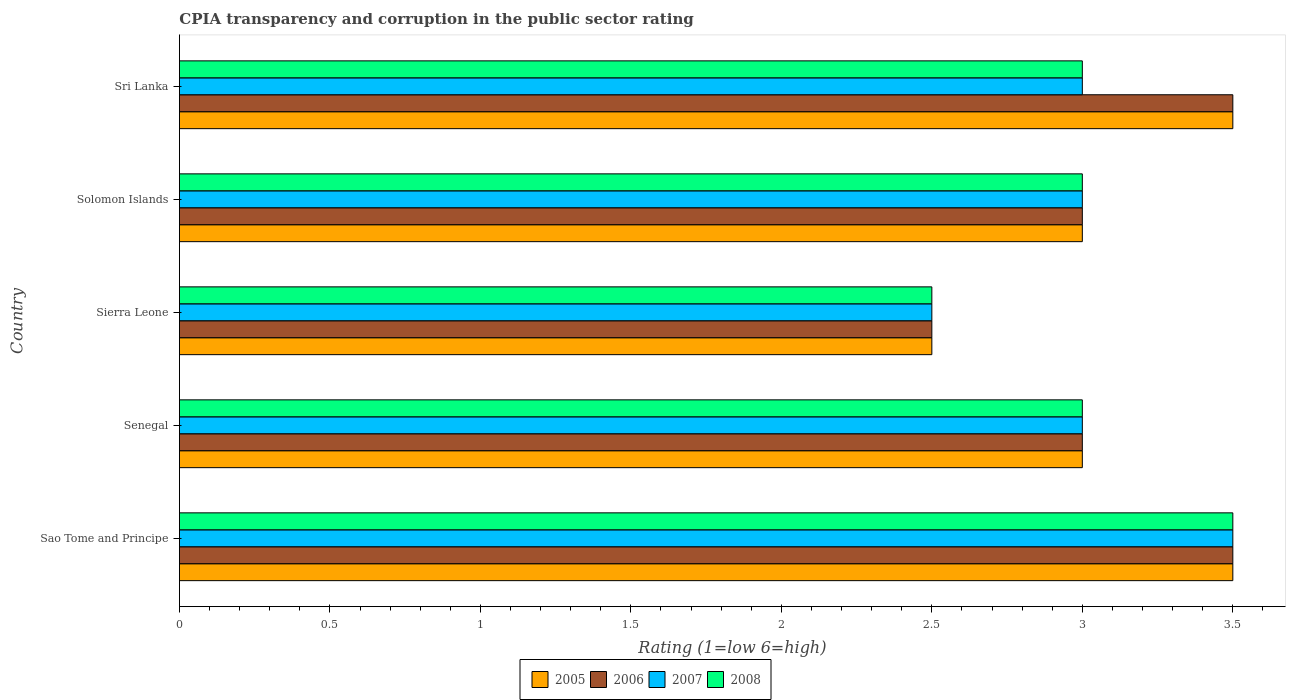How many different coloured bars are there?
Provide a succinct answer. 4. Are the number of bars per tick equal to the number of legend labels?
Offer a terse response. Yes. How many bars are there on the 1st tick from the bottom?
Your answer should be very brief. 4. What is the label of the 2nd group of bars from the top?
Your response must be concise. Solomon Islands. In how many cases, is the number of bars for a given country not equal to the number of legend labels?
Offer a very short reply. 0. Across all countries, what is the minimum CPIA rating in 2006?
Make the answer very short. 2.5. In which country was the CPIA rating in 2008 maximum?
Provide a succinct answer. Sao Tome and Principe. In which country was the CPIA rating in 2005 minimum?
Offer a very short reply. Sierra Leone. What is the total CPIA rating in 2008 in the graph?
Your answer should be very brief. 15. In how many countries, is the CPIA rating in 2007 greater than 1.3 ?
Ensure brevity in your answer.  5. What is the ratio of the CPIA rating in 2005 in Senegal to that in Sri Lanka?
Ensure brevity in your answer.  0.86. Is the CPIA rating in 2006 in Sierra Leone less than that in Solomon Islands?
Your response must be concise. Yes. In how many countries, is the CPIA rating in 2007 greater than the average CPIA rating in 2007 taken over all countries?
Offer a terse response. 1. Is it the case that in every country, the sum of the CPIA rating in 2006 and CPIA rating in 2008 is greater than the sum of CPIA rating in 2007 and CPIA rating in 2005?
Keep it short and to the point. No. Is it the case that in every country, the sum of the CPIA rating in 2006 and CPIA rating in 2008 is greater than the CPIA rating in 2005?
Make the answer very short. Yes. Are all the bars in the graph horizontal?
Provide a succinct answer. Yes. What is the difference between two consecutive major ticks on the X-axis?
Provide a succinct answer. 0.5. How are the legend labels stacked?
Offer a terse response. Horizontal. What is the title of the graph?
Offer a terse response. CPIA transparency and corruption in the public sector rating. Does "2012" appear as one of the legend labels in the graph?
Give a very brief answer. No. What is the label or title of the X-axis?
Make the answer very short. Rating (1=low 6=high). What is the label or title of the Y-axis?
Make the answer very short. Country. What is the Rating (1=low 6=high) in 2005 in Sao Tome and Principe?
Your answer should be compact. 3.5. What is the Rating (1=low 6=high) in 2008 in Sao Tome and Principe?
Provide a short and direct response. 3.5. What is the Rating (1=low 6=high) in 2006 in Senegal?
Offer a very short reply. 3. What is the Rating (1=low 6=high) of 2007 in Senegal?
Give a very brief answer. 3. What is the Rating (1=low 6=high) in 2008 in Senegal?
Ensure brevity in your answer.  3. What is the Rating (1=low 6=high) of 2007 in Sierra Leone?
Keep it short and to the point. 2.5. What is the Rating (1=low 6=high) in 2005 in Solomon Islands?
Provide a short and direct response. 3. What is the Rating (1=low 6=high) of 2007 in Solomon Islands?
Provide a succinct answer. 3. What is the Rating (1=low 6=high) in 2005 in Sri Lanka?
Ensure brevity in your answer.  3.5. What is the Rating (1=low 6=high) in 2006 in Sri Lanka?
Give a very brief answer. 3.5. What is the Rating (1=low 6=high) in 2008 in Sri Lanka?
Give a very brief answer. 3. Across all countries, what is the maximum Rating (1=low 6=high) in 2006?
Ensure brevity in your answer.  3.5. Across all countries, what is the minimum Rating (1=low 6=high) in 2006?
Make the answer very short. 2.5. Across all countries, what is the minimum Rating (1=low 6=high) in 2008?
Your answer should be very brief. 2.5. What is the total Rating (1=low 6=high) of 2005 in the graph?
Your answer should be compact. 15.5. What is the total Rating (1=low 6=high) in 2007 in the graph?
Make the answer very short. 15. What is the difference between the Rating (1=low 6=high) of 2006 in Sao Tome and Principe and that in Senegal?
Offer a terse response. 0.5. What is the difference between the Rating (1=low 6=high) in 2007 in Sao Tome and Principe and that in Senegal?
Your answer should be compact. 0.5. What is the difference between the Rating (1=low 6=high) in 2008 in Sao Tome and Principe and that in Senegal?
Make the answer very short. 0.5. What is the difference between the Rating (1=low 6=high) of 2005 in Sao Tome and Principe and that in Solomon Islands?
Your answer should be very brief. 0.5. What is the difference between the Rating (1=low 6=high) of 2007 in Sao Tome and Principe and that in Solomon Islands?
Your answer should be very brief. 0.5. What is the difference between the Rating (1=low 6=high) in 2008 in Sao Tome and Principe and that in Solomon Islands?
Offer a terse response. 0.5. What is the difference between the Rating (1=low 6=high) in 2007 in Sao Tome and Principe and that in Sri Lanka?
Your response must be concise. 0.5. What is the difference between the Rating (1=low 6=high) of 2008 in Sao Tome and Principe and that in Sri Lanka?
Ensure brevity in your answer.  0.5. What is the difference between the Rating (1=low 6=high) of 2007 in Senegal and that in Sierra Leone?
Ensure brevity in your answer.  0.5. What is the difference between the Rating (1=low 6=high) in 2007 in Senegal and that in Solomon Islands?
Keep it short and to the point. 0. What is the difference between the Rating (1=low 6=high) in 2006 in Senegal and that in Sri Lanka?
Provide a short and direct response. -0.5. What is the difference between the Rating (1=low 6=high) in 2008 in Senegal and that in Sri Lanka?
Provide a succinct answer. 0. What is the difference between the Rating (1=low 6=high) in 2005 in Sierra Leone and that in Sri Lanka?
Offer a very short reply. -1. What is the difference between the Rating (1=low 6=high) of 2007 in Sierra Leone and that in Sri Lanka?
Provide a short and direct response. -0.5. What is the difference between the Rating (1=low 6=high) of 2007 in Solomon Islands and that in Sri Lanka?
Ensure brevity in your answer.  0. What is the difference between the Rating (1=low 6=high) in 2008 in Solomon Islands and that in Sri Lanka?
Offer a terse response. 0. What is the difference between the Rating (1=low 6=high) in 2005 in Sao Tome and Principe and the Rating (1=low 6=high) in 2007 in Senegal?
Your answer should be compact. 0.5. What is the difference between the Rating (1=low 6=high) of 2006 in Sao Tome and Principe and the Rating (1=low 6=high) of 2007 in Senegal?
Provide a succinct answer. 0.5. What is the difference between the Rating (1=low 6=high) of 2006 in Sao Tome and Principe and the Rating (1=low 6=high) of 2008 in Senegal?
Your response must be concise. 0.5. What is the difference between the Rating (1=low 6=high) in 2007 in Sao Tome and Principe and the Rating (1=low 6=high) in 2008 in Senegal?
Keep it short and to the point. 0.5. What is the difference between the Rating (1=low 6=high) of 2005 in Sao Tome and Principe and the Rating (1=low 6=high) of 2006 in Sierra Leone?
Give a very brief answer. 1. What is the difference between the Rating (1=low 6=high) of 2005 in Sao Tome and Principe and the Rating (1=low 6=high) of 2008 in Sierra Leone?
Keep it short and to the point. 1. What is the difference between the Rating (1=low 6=high) in 2006 in Sao Tome and Principe and the Rating (1=low 6=high) in 2007 in Sierra Leone?
Your answer should be very brief. 1. What is the difference between the Rating (1=low 6=high) of 2006 in Sao Tome and Principe and the Rating (1=low 6=high) of 2008 in Sierra Leone?
Offer a very short reply. 1. What is the difference between the Rating (1=low 6=high) in 2005 in Sao Tome and Principe and the Rating (1=low 6=high) in 2007 in Solomon Islands?
Provide a short and direct response. 0.5. What is the difference between the Rating (1=low 6=high) of 2006 in Sao Tome and Principe and the Rating (1=low 6=high) of 2007 in Solomon Islands?
Ensure brevity in your answer.  0.5. What is the difference between the Rating (1=low 6=high) in 2006 in Sao Tome and Principe and the Rating (1=low 6=high) in 2008 in Solomon Islands?
Provide a short and direct response. 0.5. What is the difference between the Rating (1=low 6=high) of 2006 in Sao Tome and Principe and the Rating (1=low 6=high) of 2008 in Sri Lanka?
Your answer should be very brief. 0.5. What is the difference between the Rating (1=low 6=high) of 2007 in Sao Tome and Principe and the Rating (1=low 6=high) of 2008 in Sri Lanka?
Give a very brief answer. 0.5. What is the difference between the Rating (1=low 6=high) of 2005 in Senegal and the Rating (1=low 6=high) of 2007 in Sierra Leone?
Give a very brief answer. 0.5. What is the difference between the Rating (1=low 6=high) in 2005 in Senegal and the Rating (1=low 6=high) in 2008 in Sierra Leone?
Provide a short and direct response. 0.5. What is the difference between the Rating (1=low 6=high) in 2005 in Senegal and the Rating (1=low 6=high) in 2006 in Solomon Islands?
Your answer should be very brief. 0. What is the difference between the Rating (1=low 6=high) of 2005 in Senegal and the Rating (1=low 6=high) of 2008 in Solomon Islands?
Offer a terse response. 0. What is the difference between the Rating (1=low 6=high) in 2006 in Senegal and the Rating (1=low 6=high) in 2008 in Solomon Islands?
Offer a very short reply. 0. What is the difference between the Rating (1=low 6=high) of 2007 in Senegal and the Rating (1=low 6=high) of 2008 in Solomon Islands?
Keep it short and to the point. 0. What is the difference between the Rating (1=low 6=high) in 2005 in Senegal and the Rating (1=low 6=high) in 2006 in Sri Lanka?
Keep it short and to the point. -0.5. What is the difference between the Rating (1=low 6=high) of 2007 in Senegal and the Rating (1=low 6=high) of 2008 in Sri Lanka?
Provide a succinct answer. 0. What is the difference between the Rating (1=low 6=high) in 2006 in Sierra Leone and the Rating (1=low 6=high) in 2007 in Solomon Islands?
Make the answer very short. -0.5. What is the difference between the Rating (1=low 6=high) of 2005 in Sierra Leone and the Rating (1=low 6=high) of 2006 in Sri Lanka?
Your answer should be very brief. -1. What is the difference between the Rating (1=low 6=high) in 2006 in Sierra Leone and the Rating (1=low 6=high) in 2008 in Sri Lanka?
Offer a very short reply. -0.5. What is the difference between the Rating (1=low 6=high) in 2005 in Solomon Islands and the Rating (1=low 6=high) in 2006 in Sri Lanka?
Provide a short and direct response. -0.5. What is the difference between the Rating (1=low 6=high) in 2006 in Solomon Islands and the Rating (1=low 6=high) in 2007 in Sri Lanka?
Make the answer very short. 0. What is the difference between the Rating (1=low 6=high) in 2007 in Solomon Islands and the Rating (1=low 6=high) in 2008 in Sri Lanka?
Keep it short and to the point. 0. What is the average Rating (1=low 6=high) in 2006 per country?
Ensure brevity in your answer.  3.1. What is the average Rating (1=low 6=high) of 2008 per country?
Your response must be concise. 3. What is the difference between the Rating (1=low 6=high) of 2005 and Rating (1=low 6=high) of 2006 in Sao Tome and Principe?
Offer a very short reply. 0. What is the difference between the Rating (1=low 6=high) in 2006 and Rating (1=low 6=high) in 2007 in Sao Tome and Principe?
Provide a short and direct response. 0. What is the difference between the Rating (1=low 6=high) of 2005 and Rating (1=low 6=high) of 2006 in Senegal?
Provide a short and direct response. 0. What is the difference between the Rating (1=low 6=high) of 2006 and Rating (1=low 6=high) of 2008 in Senegal?
Make the answer very short. 0. What is the difference between the Rating (1=low 6=high) in 2005 and Rating (1=low 6=high) in 2006 in Sierra Leone?
Keep it short and to the point. 0. What is the difference between the Rating (1=low 6=high) in 2005 and Rating (1=low 6=high) in 2007 in Sierra Leone?
Your answer should be very brief. 0. What is the difference between the Rating (1=low 6=high) of 2005 and Rating (1=low 6=high) of 2008 in Sierra Leone?
Your response must be concise. 0. What is the difference between the Rating (1=low 6=high) in 2006 and Rating (1=low 6=high) in 2008 in Sierra Leone?
Your answer should be very brief. 0. What is the difference between the Rating (1=low 6=high) of 2005 and Rating (1=low 6=high) of 2008 in Solomon Islands?
Your answer should be compact. 0. What is the difference between the Rating (1=low 6=high) of 2006 and Rating (1=low 6=high) of 2007 in Solomon Islands?
Make the answer very short. 0. What is the difference between the Rating (1=low 6=high) in 2006 and Rating (1=low 6=high) in 2008 in Solomon Islands?
Offer a very short reply. 0. What is the difference between the Rating (1=low 6=high) of 2007 and Rating (1=low 6=high) of 2008 in Solomon Islands?
Your answer should be compact. 0. What is the ratio of the Rating (1=low 6=high) in 2005 in Sao Tome and Principe to that in Senegal?
Give a very brief answer. 1.17. What is the ratio of the Rating (1=low 6=high) of 2008 in Sao Tome and Principe to that in Senegal?
Your answer should be compact. 1.17. What is the ratio of the Rating (1=low 6=high) of 2007 in Sao Tome and Principe to that in Sierra Leone?
Give a very brief answer. 1.4. What is the ratio of the Rating (1=low 6=high) in 2005 in Sao Tome and Principe to that in Solomon Islands?
Offer a terse response. 1.17. What is the ratio of the Rating (1=low 6=high) of 2006 in Sao Tome and Principe to that in Solomon Islands?
Your response must be concise. 1.17. What is the ratio of the Rating (1=low 6=high) in 2007 in Sao Tome and Principe to that in Solomon Islands?
Give a very brief answer. 1.17. What is the ratio of the Rating (1=low 6=high) of 2005 in Sao Tome and Principe to that in Sri Lanka?
Make the answer very short. 1. What is the ratio of the Rating (1=low 6=high) of 2007 in Sao Tome and Principe to that in Sri Lanka?
Keep it short and to the point. 1.17. What is the ratio of the Rating (1=low 6=high) of 2008 in Sao Tome and Principe to that in Sri Lanka?
Your answer should be compact. 1.17. What is the ratio of the Rating (1=low 6=high) of 2005 in Senegal to that in Sierra Leone?
Your response must be concise. 1.2. What is the ratio of the Rating (1=low 6=high) of 2006 in Senegal to that in Sierra Leone?
Offer a terse response. 1.2. What is the ratio of the Rating (1=low 6=high) of 2007 in Senegal to that in Sierra Leone?
Ensure brevity in your answer.  1.2. What is the ratio of the Rating (1=low 6=high) of 2008 in Senegal to that in Sierra Leone?
Ensure brevity in your answer.  1.2. What is the ratio of the Rating (1=low 6=high) in 2006 in Senegal to that in Sri Lanka?
Offer a terse response. 0.86. What is the ratio of the Rating (1=low 6=high) of 2005 in Sierra Leone to that in Solomon Islands?
Provide a succinct answer. 0.83. What is the ratio of the Rating (1=low 6=high) in 2006 in Sierra Leone to that in Solomon Islands?
Provide a succinct answer. 0.83. What is the ratio of the Rating (1=low 6=high) in 2006 in Sierra Leone to that in Sri Lanka?
Provide a short and direct response. 0.71. What is the ratio of the Rating (1=low 6=high) of 2007 in Sierra Leone to that in Sri Lanka?
Provide a succinct answer. 0.83. What is the ratio of the Rating (1=low 6=high) in 2008 in Sierra Leone to that in Sri Lanka?
Give a very brief answer. 0.83. What is the ratio of the Rating (1=low 6=high) of 2005 in Solomon Islands to that in Sri Lanka?
Your response must be concise. 0.86. What is the ratio of the Rating (1=low 6=high) in 2006 in Solomon Islands to that in Sri Lanka?
Ensure brevity in your answer.  0.86. What is the ratio of the Rating (1=low 6=high) of 2007 in Solomon Islands to that in Sri Lanka?
Your response must be concise. 1. What is the difference between the highest and the second highest Rating (1=low 6=high) in 2005?
Ensure brevity in your answer.  0. What is the difference between the highest and the lowest Rating (1=low 6=high) of 2006?
Ensure brevity in your answer.  1. 